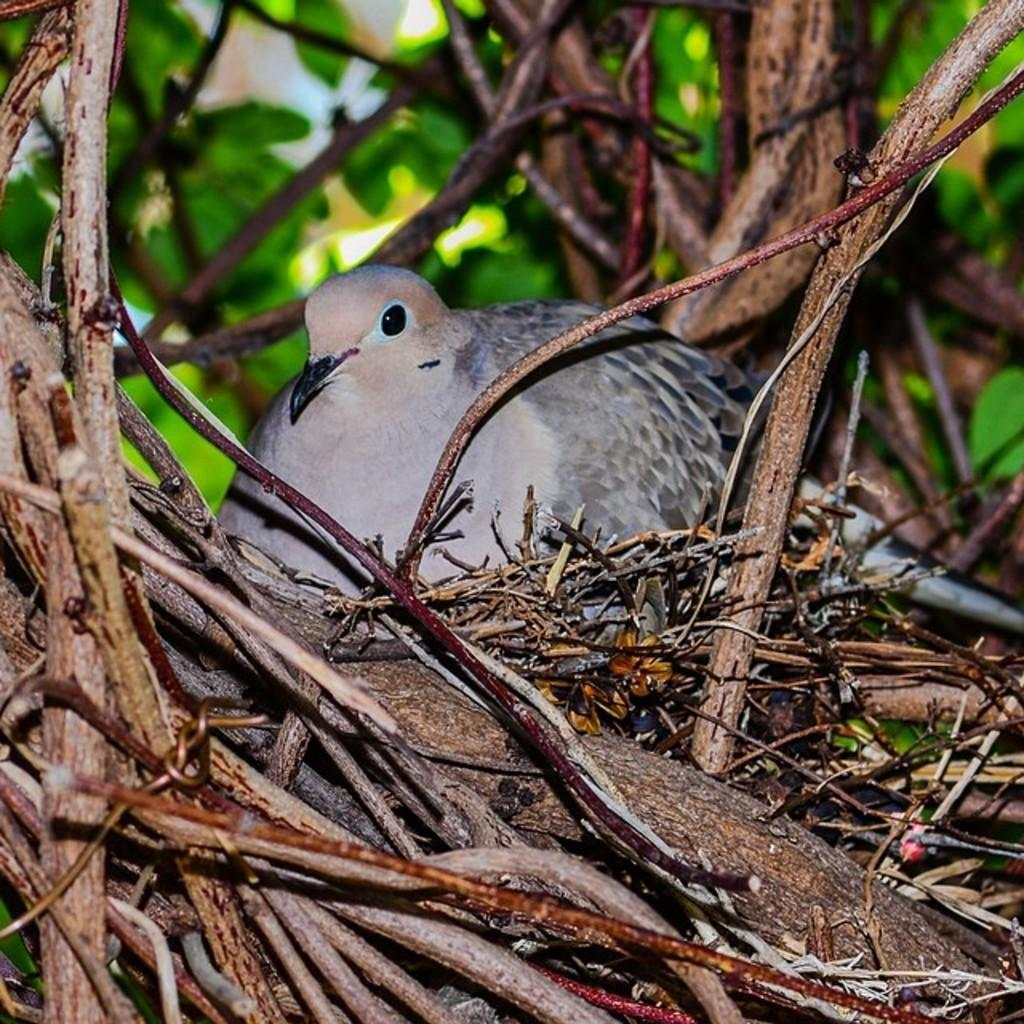What is the main object in the image? There is a tree in the image. Can you describe the bird in the image? The bird in the image has white and grey colors. What can be observed about the background of the image? The background of the image is blurred. What type of trains can be seen in the market in the image? There are no trains or markets present in the image; it features a tree and a bird. 